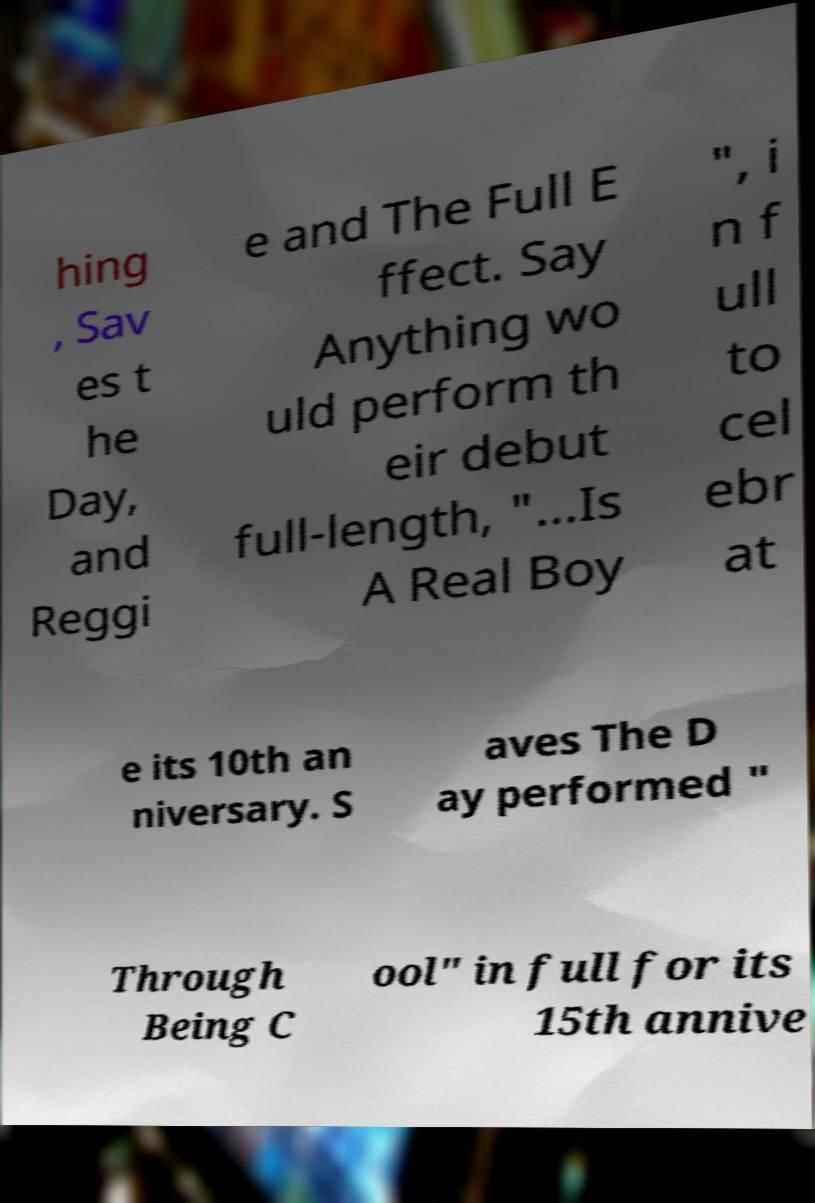Could you extract and type out the text from this image? hing , Sav es t he Day, and Reggi e and The Full E ffect. Say Anything wo uld perform th eir debut full-length, "...Is A Real Boy ", i n f ull to cel ebr at e its 10th an niversary. S aves The D ay performed " Through Being C ool" in full for its 15th annive 